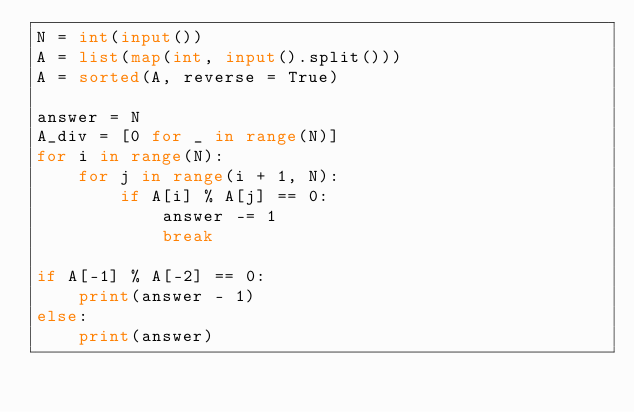Convert code to text. <code><loc_0><loc_0><loc_500><loc_500><_Python_>N = int(input())
A = list(map(int, input().split()))
A = sorted(A, reverse = True)

answer = N
A_div = [0 for _ in range(N)]
for i in range(N):
    for j in range(i + 1, N):
        if A[i] % A[j] == 0:
            answer -= 1
            break

if A[-1] % A[-2] == 0:
    print(answer - 1)
else:
    print(answer)</code> 